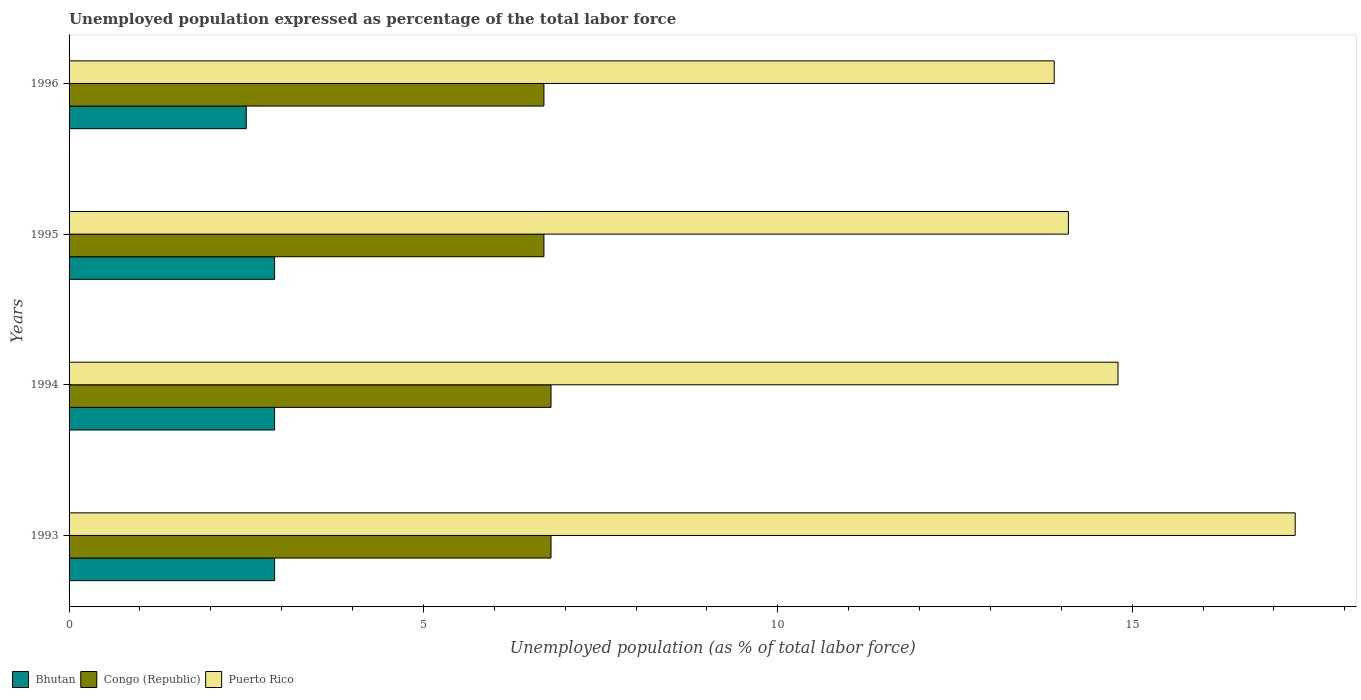How many bars are there on the 1st tick from the top?
Give a very brief answer. 3. How many bars are there on the 2nd tick from the bottom?
Provide a succinct answer. 3. In how many cases, is the number of bars for a given year not equal to the number of legend labels?
Offer a terse response. 0. What is the unemployment in in Bhutan in 1994?
Ensure brevity in your answer.  2.9. Across all years, what is the maximum unemployment in in Congo (Republic)?
Give a very brief answer. 6.8. Across all years, what is the minimum unemployment in in Congo (Republic)?
Give a very brief answer. 6.7. In which year was the unemployment in in Bhutan maximum?
Give a very brief answer. 1993. What is the total unemployment in in Puerto Rico in the graph?
Your response must be concise. 60.1. What is the difference between the unemployment in in Bhutan in 1994 and that in 1995?
Give a very brief answer. 0. What is the difference between the unemployment in in Congo (Republic) in 1996 and the unemployment in in Puerto Rico in 1995?
Provide a succinct answer. -7.4. What is the average unemployment in in Congo (Republic) per year?
Offer a very short reply. 6.75. In the year 1993, what is the difference between the unemployment in in Puerto Rico and unemployment in in Congo (Republic)?
Your answer should be compact. 10.5. In how many years, is the unemployment in in Bhutan greater than 6 %?
Offer a very short reply. 0. What is the ratio of the unemployment in in Puerto Rico in 1995 to that in 1996?
Your answer should be compact. 1.01. What is the difference between the highest and the lowest unemployment in in Bhutan?
Keep it short and to the point. 0.4. Is the sum of the unemployment in in Bhutan in 1994 and 1996 greater than the maximum unemployment in in Puerto Rico across all years?
Make the answer very short. No. What does the 1st bar from the top in 1995 represents?
Your response must be concise. Puerto Rico. What does the 3rd bar from the bottom in 1994 represents?
Your response must be concise. Puerto Rico. How many bars are there?
Provide a short and direct response. 12. Are all the bars in the graph horizontal?
Your answer should be compact. Yes. How many years are there in the graph?
Give a very brief answer. 4. Does the graph contain any zero values?
Offer a terse response. No. Does the graph contain grids?
Give a very brief answer. No. Where does the legend appear in the graph?
Offer a terse response. Bottom left. How are the legend labels stacked?
Your response must be concise. Horizontal. What is the title of the graph?
Make the answer very short. Unemployed population expressed as percentage of the total labor force. What is the label or title of the X-axis?
Give a very brief answer. Unemployed population (as % of total labor force). What is the label or title of the Y-axis?
Offer a terse response. Years. What is the Unemployed population (as % of total labor force) of Bhutan in 1993?
Your answer should be very brief. 2.9. What is the Unemployed population (as % of total labor force) of Congo (Republic) in 1993?
Your response must be concise. 6.8. What is the Unemployed population (as % of total labor force) of Puerto Rico in 1993?
Ensure brevity in your answer.  17.3. What is the Unemployed population (as % of total labor force) of Bhutan in 1994?
Offer a terse response. 2.9. What is the Unemployed population (as % of total labor force) of Congo (Republic) in 1994?
Provide a succinct answer. 6.8. What is the Unemployed population (as % of total labor force) in Puerto Rico in 1994?
Offer a terse response. 14.8. What is the Unemployed population (as % of total labor force) of Bhutan in 1995?
Your answer should be very brief. 2.9. What is the Unemployed population (as % of total labor force) in Congo (Republic) in 1995?
Ensure brevity in your answer.  6.7. What is the Unemployed population (as % of total labor force) in Puerto Rico in 1995?
Offer a terse response. 14.1. What is the Unemployed population (as % of total labor force) of Bhutan in 1996?
Make the answer very short. 2.5. What is the Unemployed population (as % of total labor force) of Congo (Republic) in 1996?
Your answer should be very brief. 6.7. What is the Unemployed population (as % of total labor force) of Puerto Rico in 1996?
Offer a very short reply. 13.9. Across all years, what is the maximum Unemployed population (as % of total labor force) in Bhutan?
Offer a very short reply. 2.9. Across all years, what is the maximum Unemployed population (as % of total labor force) in Congo (Republic)?
Offer a terse response. 6.8. Across all years, what is the maximum Unemployed population (as % of total labor force) of Puerto Rico?
Make the answer very short. 17.3. Across all years, what is the minimum Unemployed population (as % of total labor force) of Congo (Republic)?
Provide a short and direct response. 6.7. Across all years, what is the minimum Unemployed population (as % of total labor force) in Puerto Rico?
Your answer should be very brief. 13.9. What is the total Unemployed population (as % of total labor force) in Puerto Rico in the graph?
Your response must be concise. 60.1. What is the difference between the Unemployed population (as % of total labor force) in Bhutan in 1993 and that in 1995?
Offer a very short reply. 0. What is the difference between the Unemployed population (as % of total labor force) of Bhutan in 1993 and that in 1996?
Your response must be concise. 0.4. What is the difference between the Unemployed population (as % of total labor force) in Congo (Republic) in 1993 and that in 1996?
Provide a succinct answer. 0.1. What is the difference between the Unemployed population (as % of total labor force) in Puerto Rico in 1993 and that in 1996?
Make the answer very short. 3.4. What is the difference between the Unemployed population (as % of total labor force) in Bhutan in 1994 and that in 1995?
Ensure brevity in your answer.  0. What is the difference between the Unemployed population (as % of total labor force) of Congo (Republic) in 1994 and that in 1995?
Offer a terse response. 0.1. What is the difference between the Unemployed population (as % of total labor force) of Puerto Rico in 1994 and that in 1995?
Your answer should be very brief. 0.7. What is the difference between the Unemployed population (as % of total labor force) of Puerto Rico in 1994 and that in 1996?
Give a very brief answer. 0.9. What is the difference between the Unemployed population (as % of total labor force) in Congo (Republic) in 1995 and that in 1996?
Offer a very short reply. 0. What is the difference between the Unemployed population (as % of total labor force) of Puerto Rico in 1995 and that in 1996?
Your response must be concise. 0.2. What is the difference between the Unemployed population (as % of total labor force) of Bhutan in 1993 and the Unemployed population (as % of total labor force) of Congo (Republic) in 1994?
Ensure brevity in your answer.  -3.9. What is the difference between the Unemployed population (as % of total labor force) in Bhutan in 1993 and the Unemployed population (as % of total labor force) in Puerto Rico in 1994?
Make the answer very short. -11.9. What is the difference between the Unemployed population (as % of total labor force) of Congo (Republic) in 1993 and the Unemployed population (as % of total labor force) of Puerto Rico in 1994?
Offer a very short reply. -8. What is the difference between the Unemployed population (as % of total labor force) of Bhutan in 1993 and the Unemployed population (as % of total labor force) of Puerto Rico in 1995?
Provide a short and direct response. -11.2. What is the difference between the Unemployed population (as % of total labor force) in Congo (Republic) in 1993 and the Unemployed population (as % of total labor force) in Puerto Rico in 1995?
Offer a very short reply. -7.3. What is the difference between the Unemployed population (as % of total labor force) of Bhutan in 1993 and the Unemployed population (as % of total labor force) of Congo (Republic) in 1996?
Give a very brief answer. -3.8. What is the difference between the Unemployed population (as % of total labor force) in Bhutan in 1993 and the Unemployed population (as % of total labor force) in Puerto Rico in 1996?
Provide a short and direct response. -11. What is the difference between the Unemployed population (as % of total labor force) in Congo (Republic) in 1993 and the Unemployed population (as % of total labor force) in Puerto Rico in 1996?
Offer a terse response. -7.1. What is the difference between the Unemployed population (as % of total labor force) in Bhutan in 1994 and the Unemployed population (as % of total labor force) in Congo (Republic) in 1995?
Offer a very short reply. -3.8. What is the difference between the Unemployed population (as % of total labor force) of Congo (Republic) in 1994 and the Unemployed population (as % of total labor force) of Puerto Rico in 1995?
Give a very brief answer. -7.3. What is the average Unemployed population (as % of total labor force) of Congo (Republic) per year?
Your answer should be very brief. 6.75. What is the average Unemployed population (as % of total labor force) of Puerto Rico per year?
Offer a terse response. 15.03. In the year 1993, what is the difference between the Unemployed population (as % of total labor force) of Bhutan and Unemployed population (as % of total labor force) of Puerto Rico?
Your response must be concise. -14.4. In the year 1994, what is the difference between the Unemployed population (as % of total labor force) of Bhutan and Unemployed population (as % of total labor force) of Congo (Republic)?
Offer a terse response. -3.9. In the year 1995, what is the difference between the Unemployed population (as % of total labor force) of Congo (Republic) and Unemployed population (as % of total labor force) of Puerto Rico?
Your answer should be very brief. -7.4. In the year 1996, what is the difference between the Unemployed population (as % of total labor force) in Bhutan and Unemployed population (as % of total labor force) in Puerto Rico?
Offer a very short reply. -11.4. In the year 1996, what is the difference between the Unemployed population (as % of total labor force) in Congo (Republic) and Unemployed population (as % of total labor force) in Puerto Rico?
Your response must be concise. -7.2. What is the ratio of the Unemployed population (as % of total labor force) of Bhutan in 1993 to that in 1994?
Provide a short and direct response. 1. What is the ratio of the Unemployed population (as % of total labor force) of Puerto Rico in 1993 to that in 1994?
Provide a succinct answer. 1.17. What is the ratio of the Unemployed population (as % of total labor force) of Bhutan in 1993 to that in 1995?
Make the answer very short. 1. What is the ratio of the Unemployed population (as % of total labor force) in Congo (Republic) in 1993 to that in 1995?
Your answer should be very brief. 1.01. What is the ratio of the Unemployed population (as % of total labor force) of Puerto Rico in 1993 to that in 1995?
Offer a terse response. 1.23. What is the ratio of the Unemployed population (as % of total labor force) in Bhutan in 1993 to that in 1996?
Give a very brief answer. 1.16. What is the ratio of the Unemployed population (as % of total labor force) of Congo (Republic) in 1993 to that in 1996?
Ensure brevity in your answer.  1.01. What is the ratio of the Unemployed population (as % of total labor force) of Puerto Rico in 1993 to that in 1996?
Your answer should be very brief. 1.24. What is the ratio of the Unemployed population (as % of total labor force) in Congo (Republic) in 1994 to that in 1995?
Make the answer very short. 1.01. What is the ratio of the Unemployed population (as % of total labor force) of Puerto Rico in 1994 to that in 1995?
Your response must be concise. 1.05. What is the ratio of the Unemployed population (as % of total labor force) of Bhutan in 1994 to that in 1996?
Give a very brief answer. 1.16. What is the ratio of the Unemployed population (as % of total labor force) of Congo (Republic) in 1994 to that in 1996?
Ensure brevity in your answer.  1.01. What is the ratio of the Unemployed population (as % of total labor force) of Puerto Rico in 1994 to that in 1996?
Make the answer very short. 1.06. What is the ratio of the Unemployed population (as % of total labor force) in Bhutan in 1995 to that in 1996?
Make the answer very short. 1.16. What is the ratio of the Unemployed population (as % of total labor force) in Puerto Rico in 1995 to that in 1996?
Your answer should be very brief. 1.01. What is the difference between the highest and the second highest Unemployed population (as % of total labor force) of Congo (Republic)?
Your response must be concise. 0. 